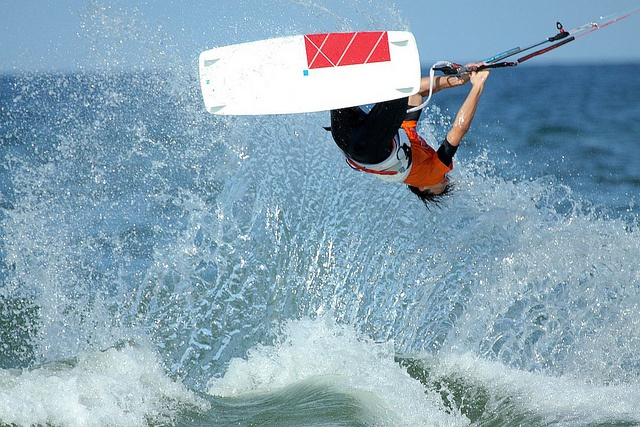Describe the objects in this image and their specific colors. I can see surfboard in darkgray, white, salmon, and red tones and people in darkgray, black, maroon, and gray tones in this image. 